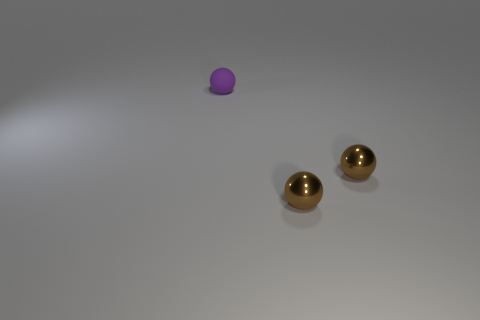Are any small purple metallic spheres visible?
Your answer should be compact. No. Is there another thing of the same color as the rubber object?
Give a very brief answer. No. How many other purple spheres are the same size as the purple ball?
Your answer should be very brief. 0. There is a tiny purple object; are there any tiny objects in front of it?
Give a very brief answer. Yes. How many other objects are the same material as the purple object?
Provide a succinct answer. 0. How many big objects are gray objects or metallic spheres?
Provide a short and direct response. 0. Are there the same number of small balls behind the small purple matte sphere and small objects?
Your response must be concise. No. How many other things are there of the same color as the matte ball?
Your answer should be compact. 0. What is the color of the matte thing?
Offer a terse response. Purple. What number of things are either balls that are in front of the small purple sphere or small metal balls?
Provide a succinct answer. 2. 